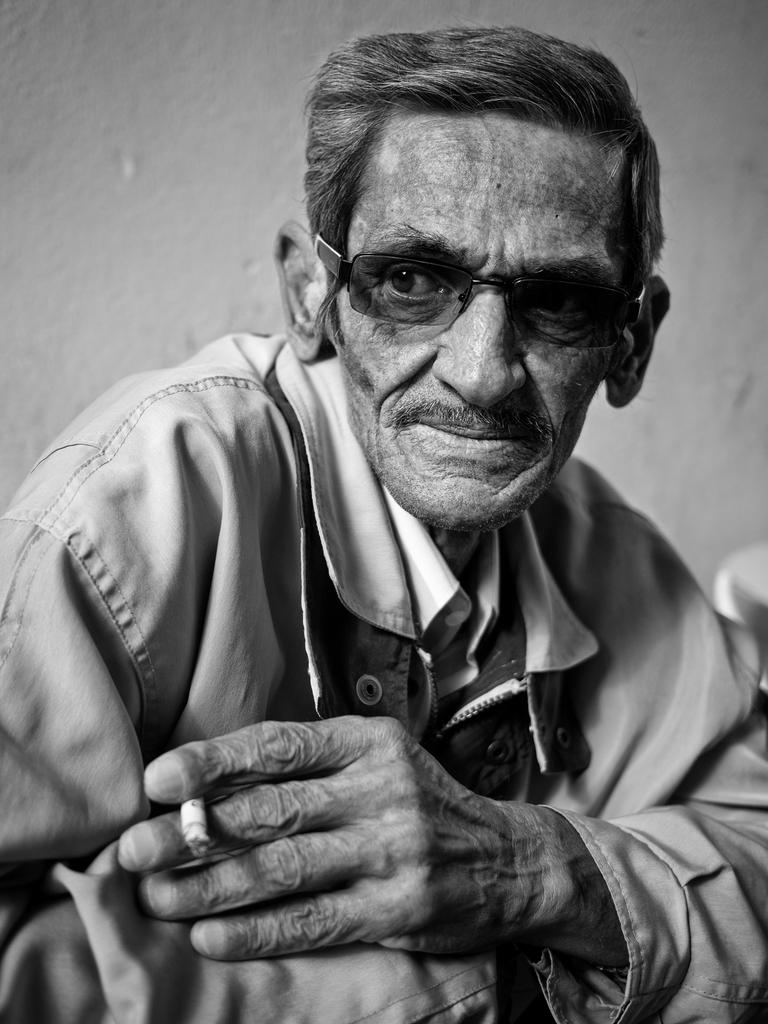What can be seen in the image? There is a person in the image. Can you describe the person's clothing? The person is wearing a shirt. Are there any accessories visible on the person? Yes, the person is wearing glasses. What is the person holding in the image? The person is holding a cigarette. What is visible in the background of the image? There is a wall in the background of the image. How is the image presented? The image is black and white. What type of noise can be heard coming from the person's shoes in the image? There is no indication of any noise coming from the person's shoes in the image, as it is a still photograph. 